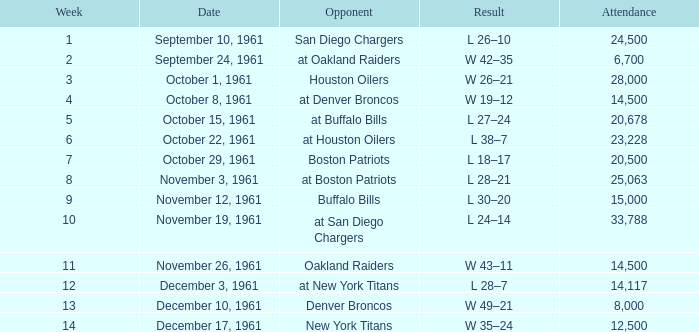What is the peak attendance for weeks following 2 on october 29, 1961? 20500.0. 